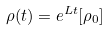Convert formula to latex. <formula><loc_0><loc_0><loc_500><loc_500>\rho ( t ) = e ^ { L t } [ \rho _ { 0 } ]</formula> 